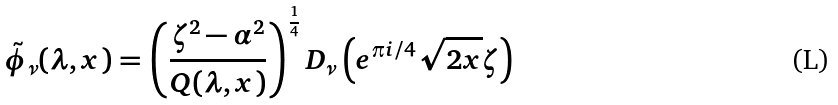Convert formula to latex. <formula><loc_0><loc_0><loc_500><loc_500>\tilde { \phi } _ { \nu } ( \lambda , x ) = \left ( \frac { \zeta ^ { 2 } - \alpha ^ { 2 } } { Q ( \lambda , x ) } \right ) ^ { \frac { 1 } { 4 } } D _ { \nu } \left ( { e } ^ { \pi i / 4 } \sqrt { 2 x } \zeta \right )</formula> 